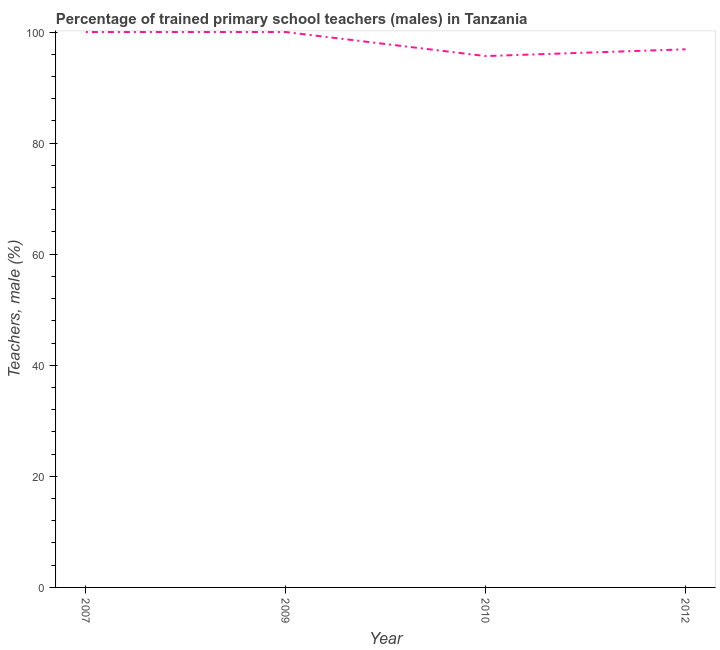What is the percentage of trained male teachers in 2010?
Keep it short and to the point. 95.67. Across all years, what is the minimum percentage of trained male teachers?
Provide a short and direct response. 95.67. What is the sum of the percentage of trained male teachers?
Your answer should be very brief. 392.56. What is the difference between the percentage of trained male teachers in 2009 and 2012?
Offer a very short reply. 3.11. What is the average percentage of trained male teachers per year?
Make the answer very short. 98.14. What is the median percentage of trained male teachers?
Give a very brief answer. 98.45. What is the ratio of the percentage of trained male teachers in 2009 to that in 2012?
Make the answer very short. 1.03. Is the difference between the percentage of trained male teachers in 2007 and 2010 greater than the difference between any two years?
Provide a short and direct response. Yes. What is the difference between the highest and the lowest percentage of trained male teachers?
Make the answer very short. 4.33. Does the percentage of trained male teachers monotonically increase over the years?
Provide a succinct answer. No. How many years are there in the graph?
Offer a terse response. 4. Does the graph contain grids?
Offer a very short reply. No. What is the title of the graph?
Make the answer very short. Percentage of trained primary school teachers (males) in Tanzania. What is the label or title of the X-axis?
Give a very brief answer. Year. What is the label or title of the Y-axis?
Make the answer very short. Teachers, male (%). What is the Teachers, male (%) in 2007?
Ensure brevity in your answer.  100. What is the Teachers, male (%) of 2010?
Make the answer very short. 95.67. What is the Teachers, male (%) of 2012?
Offer a very short reply. 96.89. What is the difference between the Teachers, male (%) in 2007 and 2010?
Your answer should be compact. 4.33. What is the difference between the Teachers, male (%) in 2007 and 2012?
Provide a succinct answer. 3.11. What is the difference between the Teachers, male (%) in 2009 and 2010?
Offer a terse response. 4.33. What is the difference between the Teachers, male (%) in 2009 and 2012?
Offer a terse response. 3.11. What is the difference between the Teachers, male (%) in 2010 and 2012?
Provide a succinct answer. -1.22. What is the ratio of the Teachers, male (%) in 2007 to that in 2009?
Keep it short and to the point. 1. What is the ratio of the Teachers, male (%) in 2007 to that in 2010?
Your answer should be very brief. 1.04. What is the ratio of the Teachers, male (%) in 2007 to that in 2012?
Keep it short and to the point. 1.03. What is the ratio of the Teachers, male (%) in 2009 to that in 2010?
Provide a succinct answer. 1.04. What is the ratio of the Teachers, male (%) in 2009 to that in 2012?
Your answer should be compact. 1.03. What is the ratio of the Teachers, male (%) in 2010 to that in 2012?
Keep it short and to the point. 0.99. 